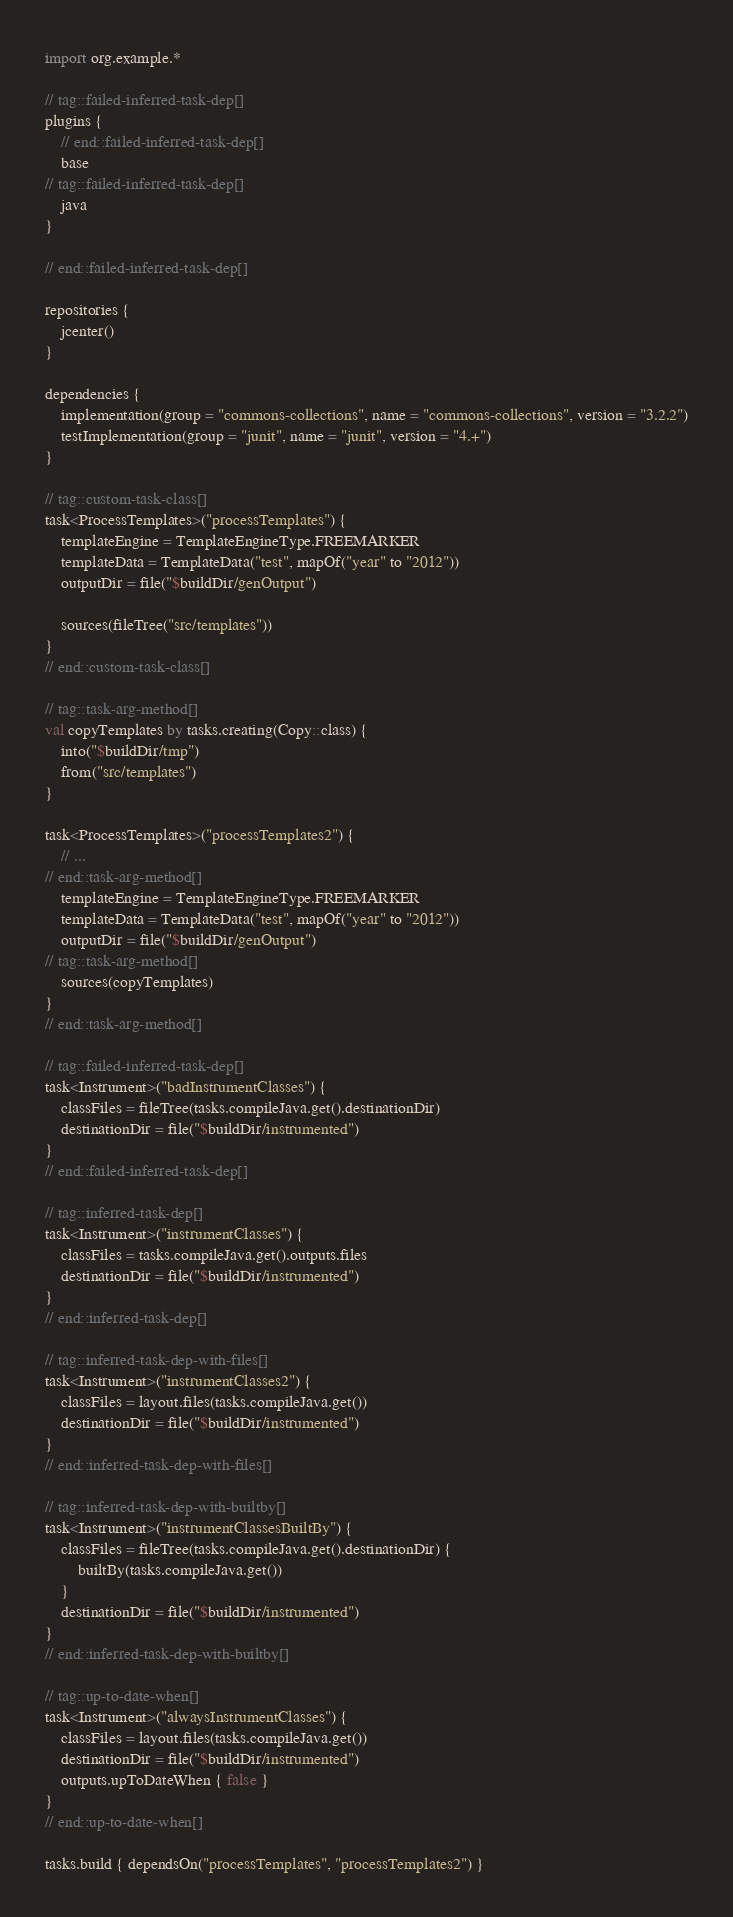<code> <loc_0><loc_0><loc_500><loc_500><_Kotlin_>import org.example.*

// tag::failed-inferred-task-dep[]
plugins {
    // end::failed-inferred-task-dep[]
    base
// tag::failed-inferred-task-dep[]
    java
}

// end::failed-inferred-task-dep[]

repositories {
    jcenter()
}

dependencies {
    implementation(group = "commons-collections", name = "commons-collections", version = "3.2.2")
    testImplementation(group = "junit", name = "junit", version = "4.+")
}

// tag::custom-task-class[]
task<ProcessTemplates>("processTemplates") {
    templateEngine = TemplateEngineType.FREEMARKER
    templateData = TemplateData("test", mapOf("year" to "2012"))
    outputDir = file("$buildDir/genOutput")

    sources(fileTree("src/templates"))
}
// end::custom-task-class[]

// tag::task-arg-method[]
val copyTemplates by tasks.creating(Copy::class) {
    into("$buildDir/tmp")
    from("src/templates")
}

task<ProcessTemplates>("processTemplates2") {
    // ...
// end::task-arg-method[]
    templateEngine = TemplateEngineType.FREEMARKER
    templateData = TemplateData("test", mapOf("year" to "2012"))
    outputDir = file("$buildDir/genOutput")
// tag::task-arg-method[]
    sources(copyTemplates)
}
// end::task-arg-method[]

// tag::failed-inferred-task-dep[]
task<Instrument>("badInstrumentClasses") {
    classFiles = fileTree(tasks.compileJava.get().destinationDir)
    destinationDir = file("$buildDir/instrumented")
}
// end::failed-inferred-task-dep[]

// tag::inferred-task-dep[]
task<Instrument>("instrumentClasses") {
    classFiles = tasks.compileJava.get().outputs.files
    destinationDir = file("$buildDir/instrumented")
}
// end::inferred-task-dep[]

// tag::inferred-task-dep-with-files[]
task<Instrument>("instrumentClasses2") {
    classFiles = layout.files(tasks.compileJava.get())
    destinationDir = file("$buildDir/instrumented")
}
// end::inferred-task-dep-with-files[]

// tag::inferred-task-dep-with-builtby[]
task<Instrument>("instrumentClassesBuiltBy") {
    classFiles = fileTree(tasks.compileJava.get().destinationDir) {
        builtBy(tasks.compileJava.get())
    }
    destinationDir = file("$buildDir/instrumented")
}
// end::inferred-task-dep-with-builtby[]

// tag::up-to-date-when[]
task<Instrument>("alwaysInstrumentClasses") {
    classFiles = layout.files(tasks.compileJava.get())
    destinationDir = file("$buildDir/instrumented")
    outputs.upToDateWhen { false }
}
// end::up-to-date-when[]

tasks.build { dependsOn("processTemplates", "processTemplates2") }
</code> 